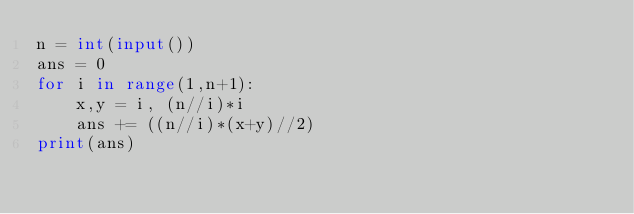Convert code to text. <code><loc_0><loc_0><loc_500><loc_500><_Python_>n = int(input())
ans = 0
for i in range(1,n+1):
    x,y = i, (n//i)*i
    ans += ((n//i)*(x+y)//2)
print(ans)</code> 